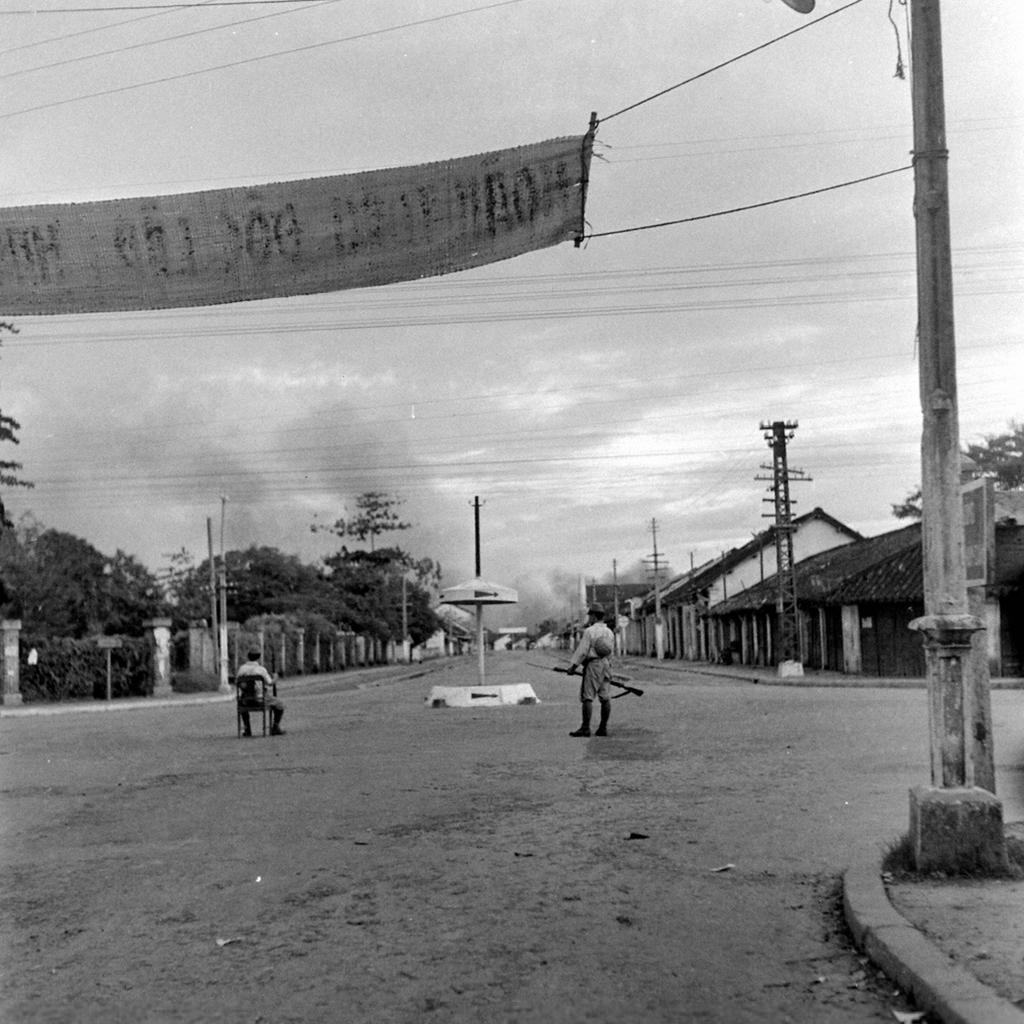How would you summarize this image in a sentence or two? In this image I can see few houses, poles, wires, current pole and few trees. I can see the person is standing and holding something and another person is sitting on the chair. In front I can see the banner is tied to the pole. 